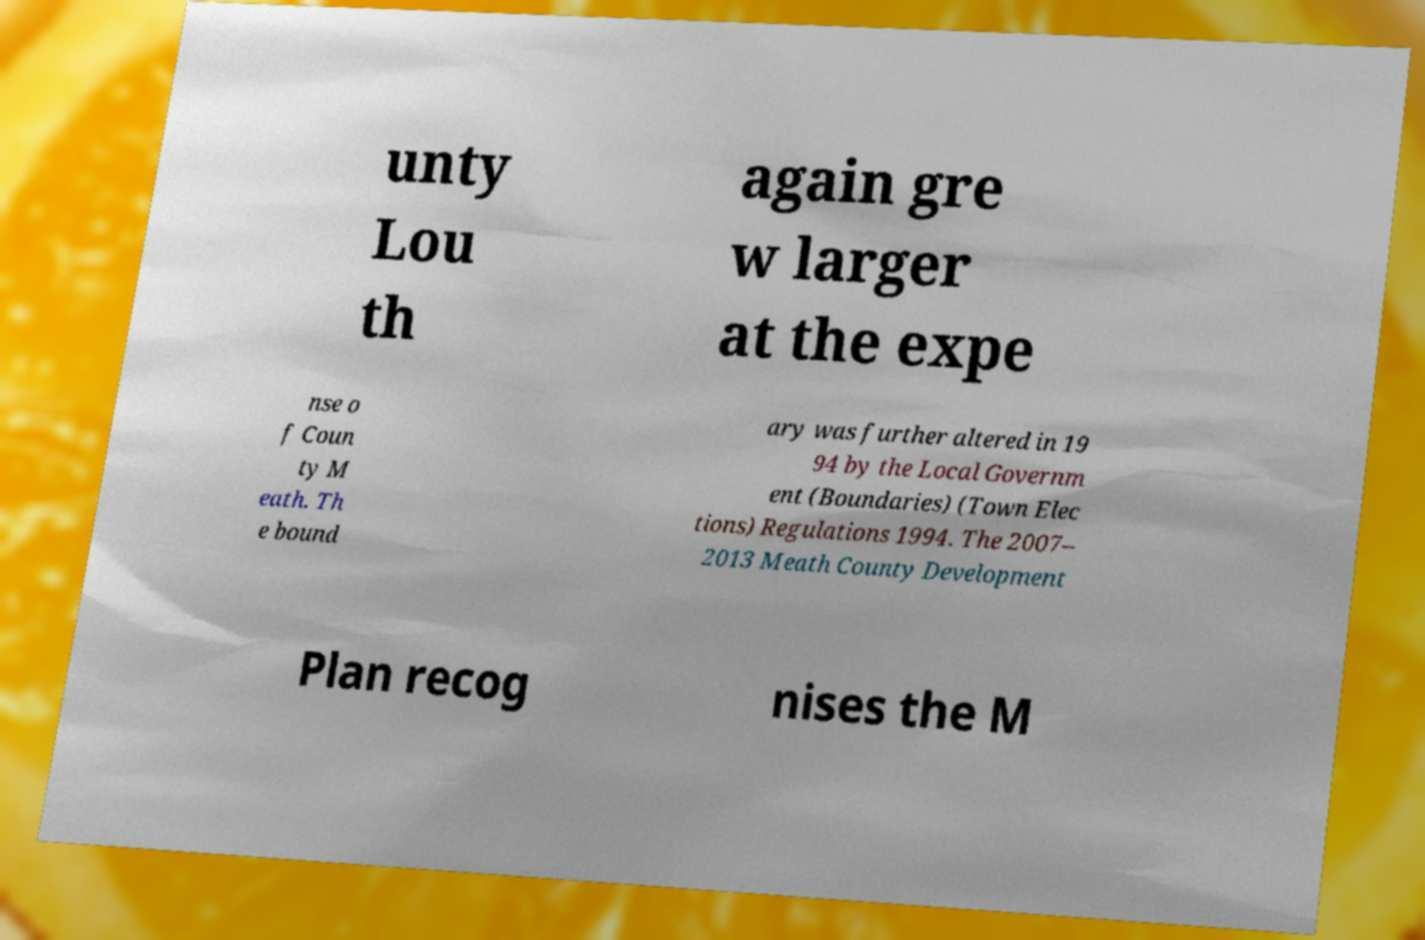Please identify and transcribe the text found in this image. unty Lou th again gre w larger at the expe nse o f Coun ty M eath. Th e bound ary was further altered in 19 94 by the Local Governm ent (Boundaries) (Town Elec tions) Regulations 1994. The 2007– 2013 Meath County Development Plan recog nises the M 